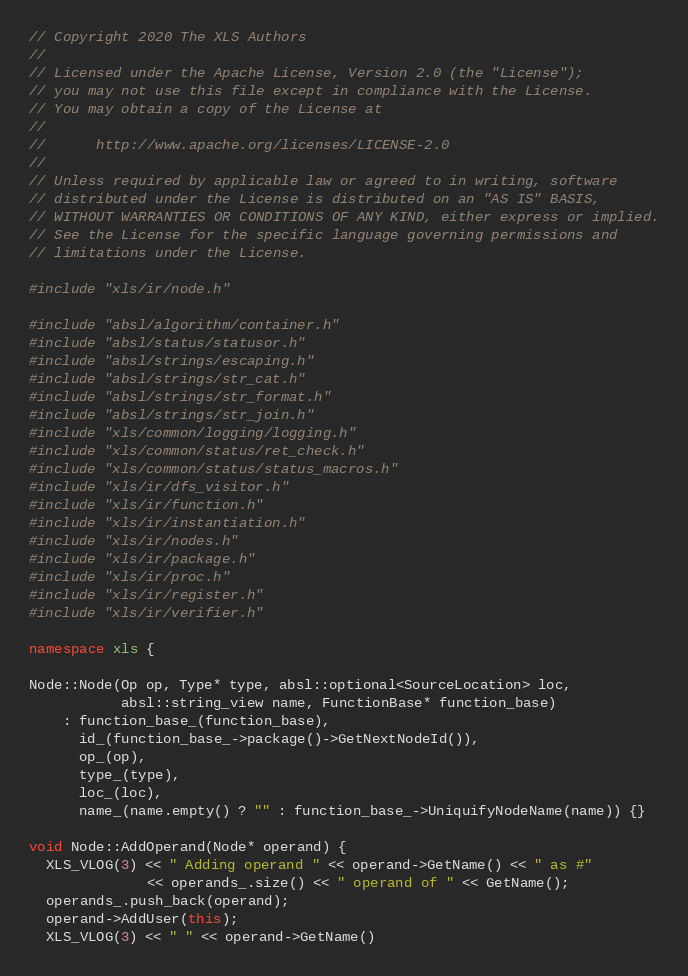<code> <loc_0><loc_0><loc_500><loc_500><_C++_>// Copyright 2020 The XLS Authors
//
// Licensed under the Apache License, Version 2.0 (the "License");
// you may not use this file except in compliance with the License.
// You may obtain a copy of the License at
//
//      http://www.apache.org/licenses/LICENSE-2.0
//
// Unless required by applicable law or agreed to in writing, software
// distributed under the License is distributed on an "AS IS" BASIS,
// WITHOUT WARRANTIES OR CONDITIONS OF ANY KIND, either express or implied.
// See the License for the specific language governing permissions and
// limitations under the License.

#include "xls/ir/node.h"

#include "absl/algorithm/container.h"
#include "absl/status/statusor.h"
#include "absl/strings/escaping.h"
#include "absl/strings/str_cat.h"
#include "absl/strings/str_format.h"
#include "absl/strings/str_join.h"
#include "xls/common/logging/logging.h"
#include "xls/common/status/ret_check.h"
#include "xls/common/status/status_macros.h"
#include "xls/ir/dfs_visitor.h"
#include "xls/ir/function.h"
#include "xls/ir/instantiation.h"
#include "xls/ir/nodes.h"
#include "xls/ir/package.h"
#include "xls/ir/proc.h"
#include "xls/ir/register.h"
#include "xls/ir/verifier.h"

namespace xls {

Node::Node(Op op, Type* type, absl::optional<SourceLocation> loc,
           absl::string_view name, FunctionBase* function_base)
    : function_base_(function_base),
      id_(function_base_->package()->GetNextNodeId()),
      op_(op),
      type_(type),
      loc_(loc),
      name_(name.empty() ? "" : function_base_->UniquifyNodeName(name)) {}

void Node::AddOperand(Node* operand) {
  XLS_VLOG(3) << " Adding operand " << operand->GetName() << " as #"
              << operands_.size() << " operand of " << GetName();
  operands_.push_back(operand);
  operand->AddUser(this);
  XLS_VLOG(3) << " " << operand->GetName()</code> 